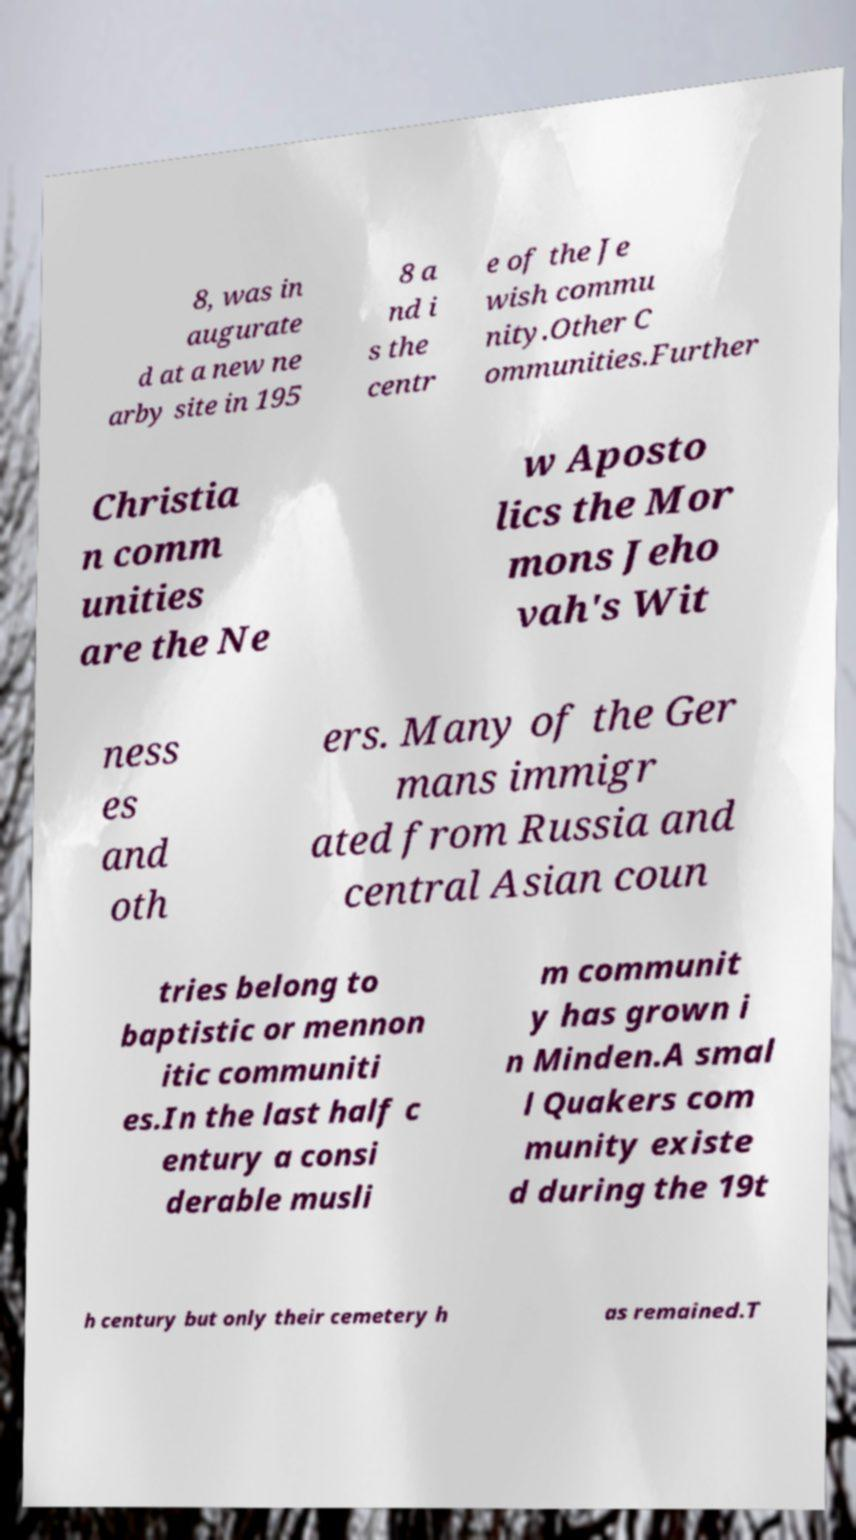Can you read and provide the text displayed in the image?This photo seems to have some interesting text. Can you extract and type it out for me? 8, was in augurate d at a new ne arby site in 195 8 a nd i s the centr e of the Je wish commu nity.Other C ommunities.Further Christia n comm unities are the Ne w Aposto lics the Mor mons Jeho vah's Wit ness es and oth ers. Many of the Ger mans immigr ated from Russia and central Asian coun tries belong to baptistic or mennon itic communiti es.In the last half c entury a consi derable musli m communit y has grown i n Minden.A smal l Quakers com munity existe d during the 19t h century but only their cemetery h as remained.T 